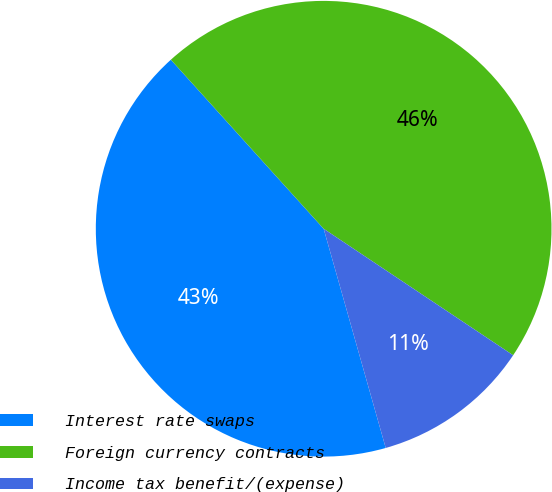Convert chart. <chart><loc_0><loc_0><loc_500><loc_500><pie_chart><fcel>Interest rate swaps<fcel>Foreign currency contracts<fcel>Income tax benefit/(expense)<nl><fcel>42.7%<fcel>46.07%<fcel>11.24%<nl></chart> 